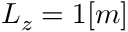<formula> <loc_0><loc_0><loc_500><loc_500>L _ { z } = 1 [ m ]</formula> 